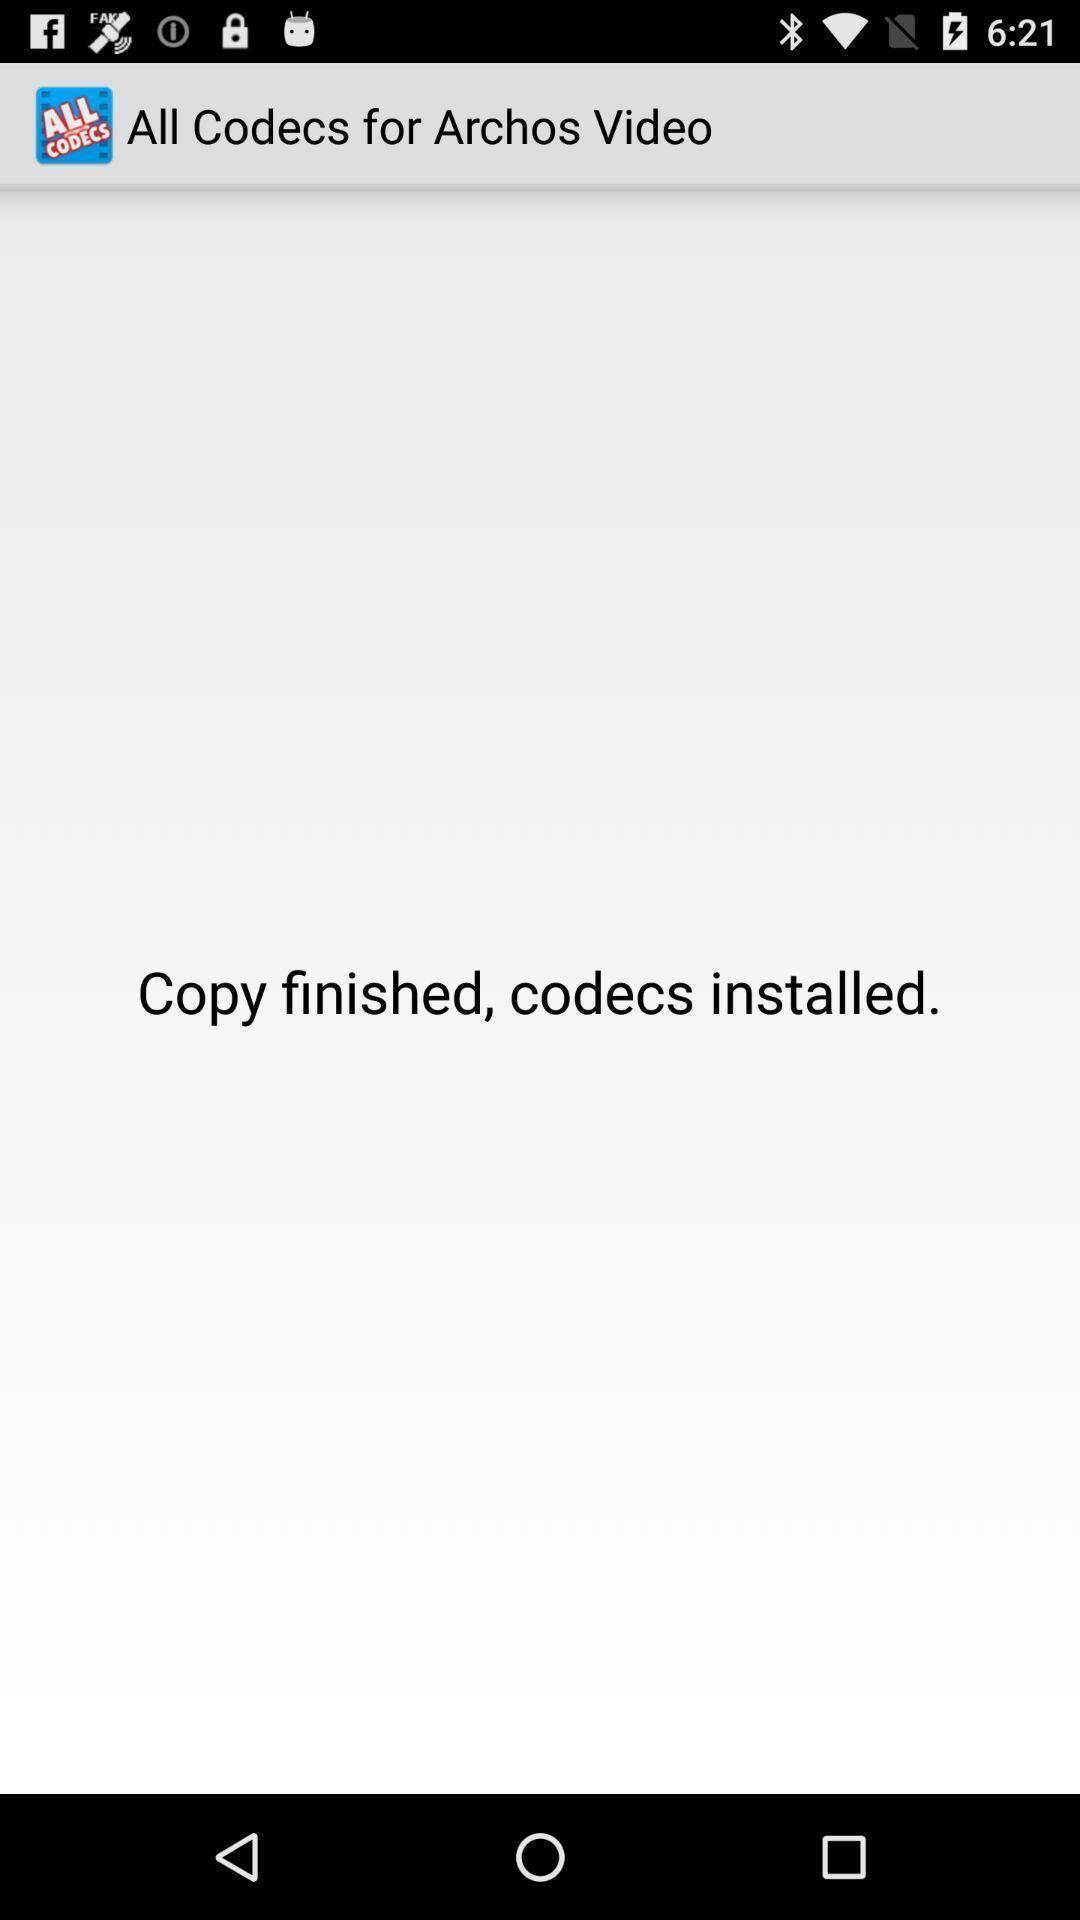Explain what's happening in this screen capture. Screen showing the content. 